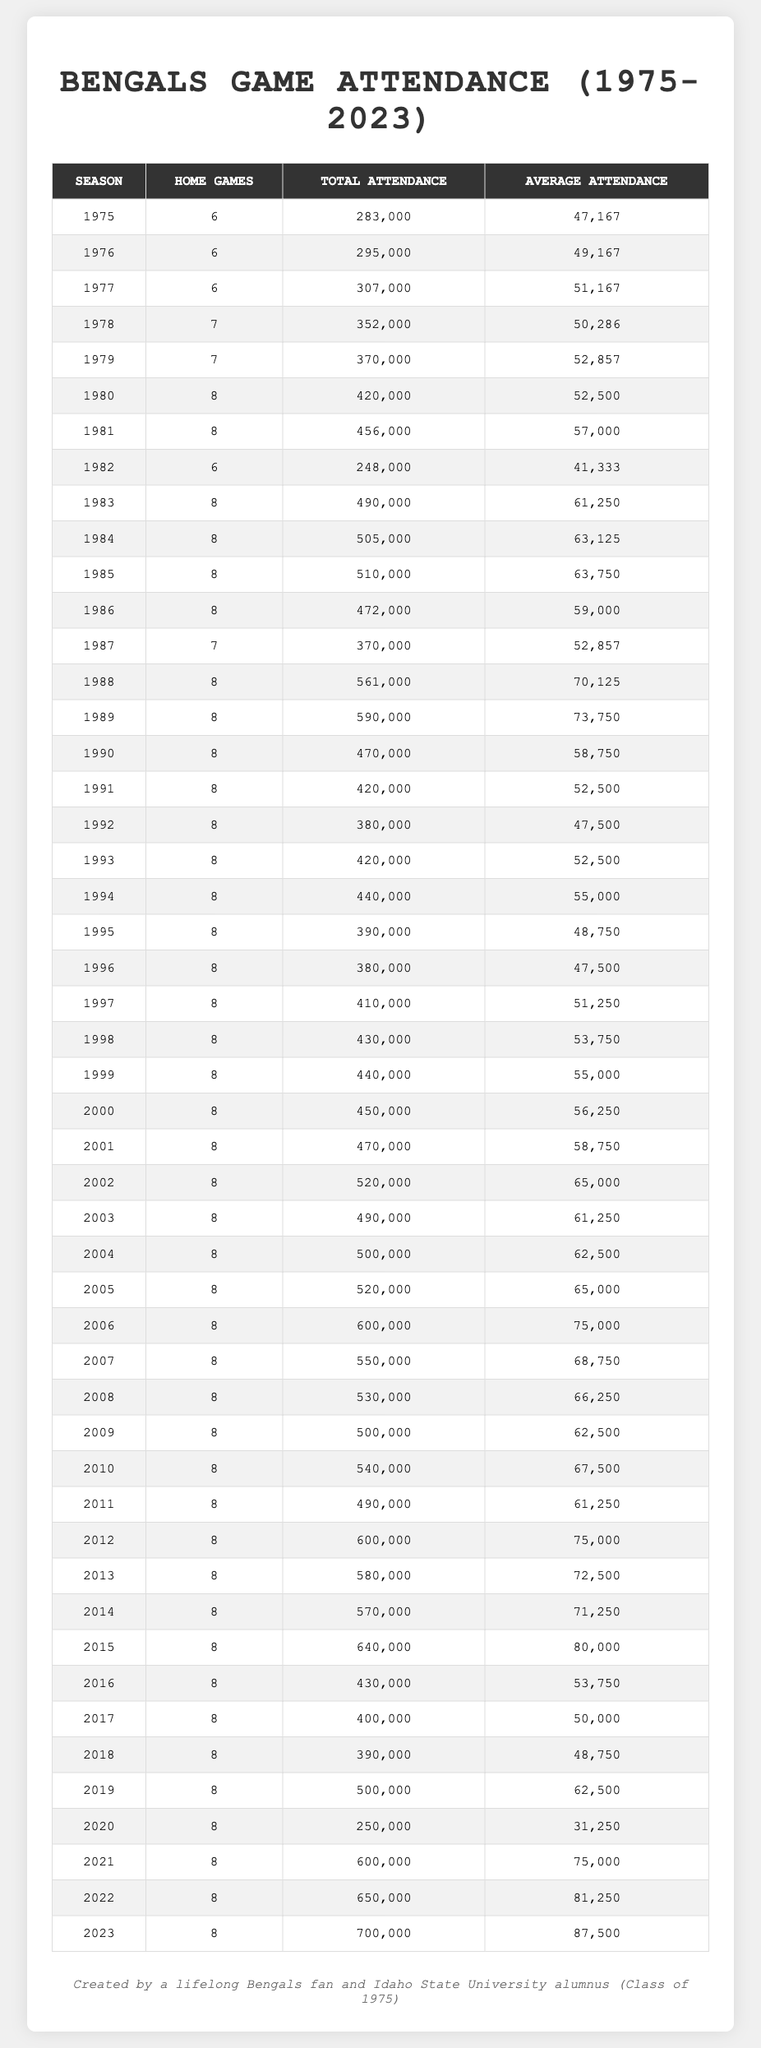What was the average attendance for the Bengals in the 1980 season? The table shows that the Total Attendance for the 1980 season was 420,000. There were 8 home games, so to find the average attendance, divide the total attendance by the number of home games: 420,000 / 8 = 52,500.
Answer: 52,500 Which season had the highest total attendance? By examining the Total Attendance column, the 2023 season had the highest total attendance of 700,000.
Answer: 2023 Did the Bengals have more home games in 1990 or 1991? Both seasons had 8 home games each, as indicated in the Home Games column. Therefore, the number of home games is the same for both years.
Answer: No What is the difference in average attendance between the 2015 and 2019 seasons? The average attendance for the 2015 season is 80,000, and for the 2019 season, it is 62,500. To find the difference, subtract the average attendance of 2019 from that of 2015: 80,000 - 62,500 = 17,500.
Answer: 17,500 What percentage of the total attendance in the 1995 season does the average attendance represent? The Total Attendance for 1995 is 390,000, and the Average Attendance is 48,750. First, we calculate the percentage: (48,750 / 390,000) * 100 = 12.5%.
Answer: 12.5% What was the total attendance for all seasons combined from 2000 to 2020? Adding the Total Attendance from 2000 to 2020: 450,000 + 470,000 + 520,000 + 490,000 + 500,000 + 520,000 + 600,000 + 550,000 + 530,000 + 500,000 + 540,000 + 490,000 + 250,000 + 600,000 = 6,830,000.
Answer: 6,830,000 In which season was the average attendance the lowest, and what was that figure? The lowest average attendance was in the 2020 season, which was 31,250, as seen in the Average Attendance column.
Answer: 2020, 31,250 What trend can be observed in average attendance from the early 2000s to 2023? The average attendance shows an upward trend from lower values in the early 2000s (around 60,000) to significantly higher values in 2022 (81,250) and 2023 (87,500), indicating increasing popularity or success of the team over these years.
Answer: Increasing trend How many more home games did the Bengals play in the 2012 season compared to the 1982 season? In the 2012 season, there were 8 home games, while in 1982, there were only 6. The difference in home games is 8 - 6 = 2.
Answer: 2 Was the total attendance in 1975 higher or lower than 300,000? The Total Attendance in 1975 was 283,000, which is lower than 300,000, as noted in the Total Attendance column.
Answer: Lower What was the average attendance in seasons where 7 home games were played? There were two seasons with 7 home games (1978 and 1979) with average attendances of 50,286 and 52,857, respectively. To find the average of these two figures: (50,286 + 52,857) / 2 = 51,571.5.
Answer: 51,571.5 